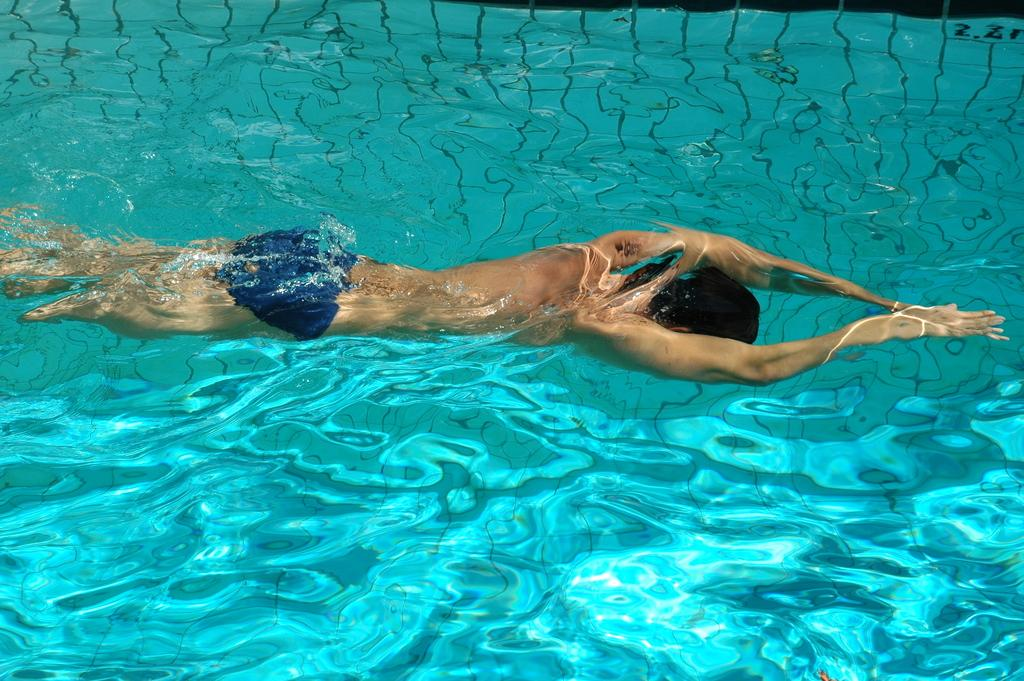What is happening in the image? There is a person in the image, and they are swimming in the water. Can you describe the person's activity in more detail? The person is swimming, which involves moving through the water using their arms and legs. What type of environment is depicted in the image? The image shows a person swimming in water, which suggests that the environment is aquatic. What railway system is visible in the image? There is no railway system present in the image; it features a person swimming in the water. What invention is the person using to swim in the image? The person is swimming using their own body, so there is no specific invention involved. 